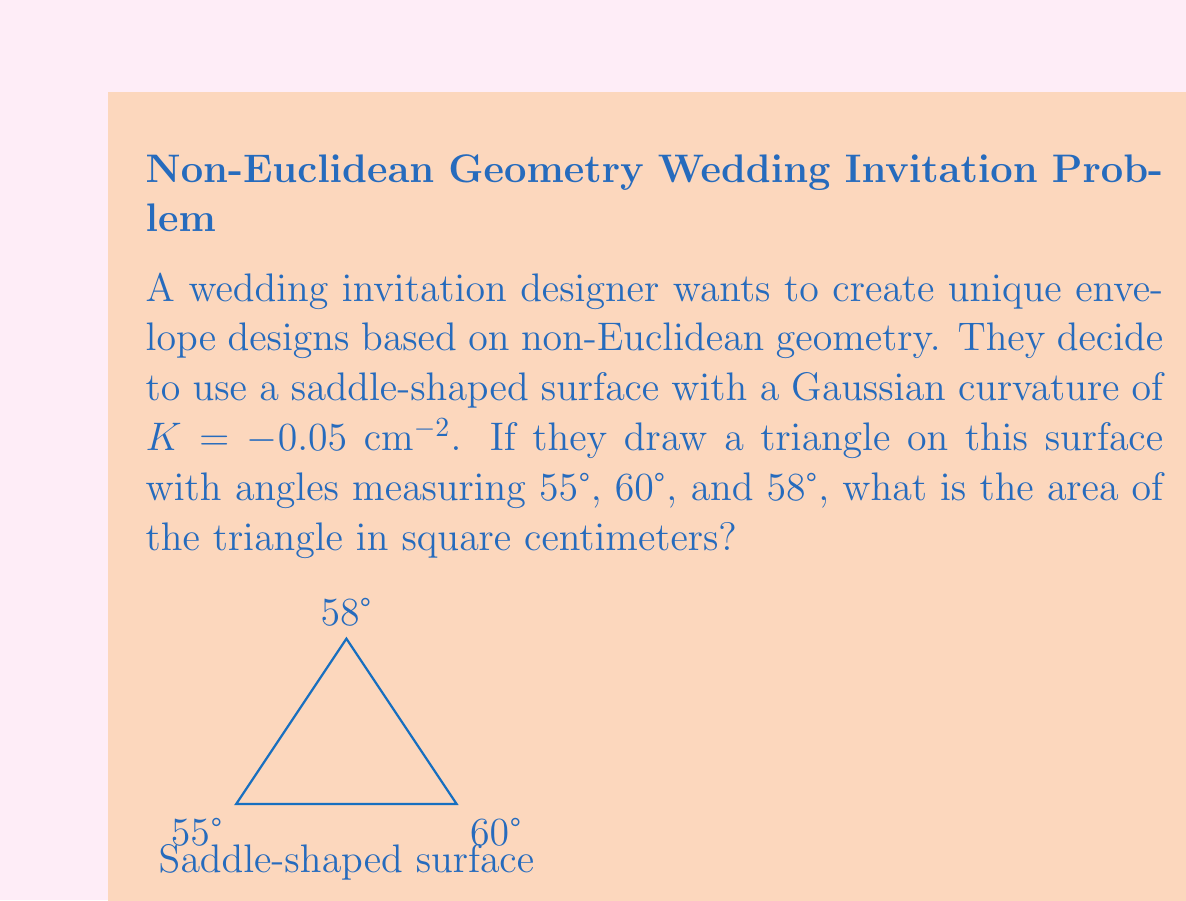Help me with this question. To solve this problem, we'll use the Gauss-Bonnet theorem, which relates the geometry of a surface to its topology. For a triangle on a surface with Gaussian curvature $K$, the theorem states:

$$\alpha + \beta + \gamma + K A = 2\pi$$

Where $\alpha$, $\beta$, and $\gamma$ are the angles of the triangle in radians, $K$ is the Gaussian curvature, and $A$ is the area of the triangle.

Step 1: Convert the given angles from degrees to radians:
$55° = \frac{55\pi}{180}$ rad
$60° = \frac{\pi}{3}$ rad
$58° = \frac{29\pi}{90}$ rad

Step 2: Sum the angles:
$$\alpha + \beta + \gamma = \frac{55\pi}{180} + \frac{\pi}{3} + \frac{29\pi}{90} = \frac{173\pi}{180} \approx 3.0194$$

Step 3: Apply the Gauss-Bonnet theorem:
$$\frac{173\pi}{180} + (-0.05 \text{ cm}^{-2})A = 2\pi$$

Step 4: Solve for $A$:
$$A = \frac{2\pi - \frac{173\pi}{180}}{-0.05 \text{ cm}^{-2}} = \frac{\frac{187\pi}{180}}{0.05 \text{ cm}^{-2}} = 65.2389 \text{ cm}^2$$

Therefore, the area of the triangle on the saddle-shaped surface is approximately 65.2389 cm².
Answer: 65.2389 cm² 